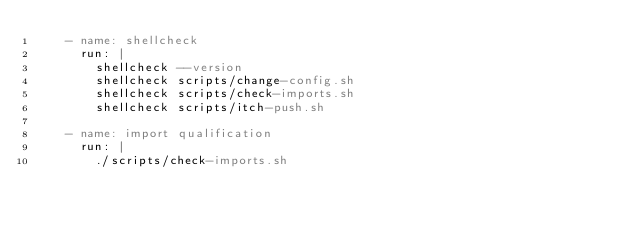Convert code to text. <code><loc_0><loc_0><loc_500><loc_500><_YAML_>    - name: shellcheck
      run: |
        shellcheck --version
        shellcheck scripts/change-config.sh
        shellcheck scripts/check-imports.sh
        shellcheck scripts/itch-push.sh

    - name: import qualification
      run: |
        ./scripts/check-imports.sh
</code> 